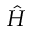<formula> <loc_0><loc_0><loc_500><loc_500>\hat { H }</formula> 